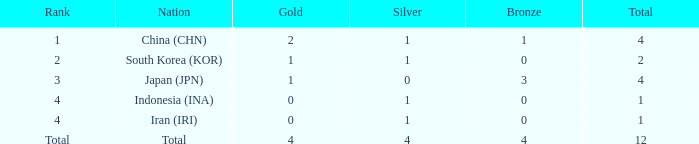What is the number of silver medals for a nation with less than one gold and a total count below one? 0.0. 